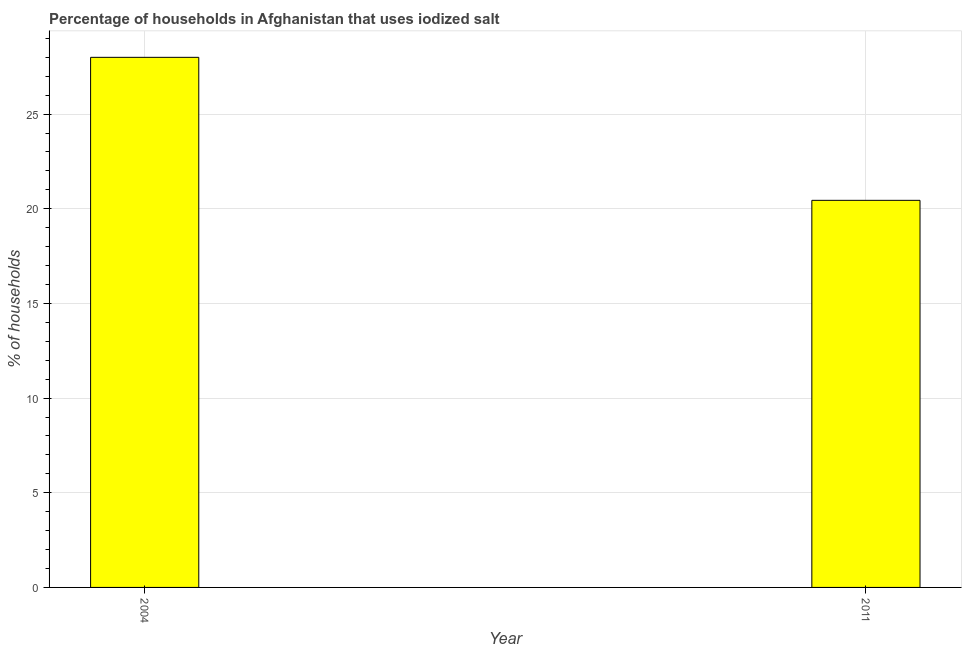Does the graph contain any zero values?
Your response must be concise. No. Does the graph contain grids?
Give a very brief answer. Yes. What is the title of the graph?
Provide a short and direct response. Percentage of households in Afghanistan that uses iodized salt. What is the label or title of the X-axis?
Your answer should be compact. Year. What is the label or title of the Y-axis?
Provide a short and direct response. % of households. Across all years, what is the minimum percentage of households where iodized salt is consumed?
Keep it short and to the point. 20.45. In which year was the percentage of households where iodized salt is consumed maximum?
Offer a very short reply. 2004. In which year was the percentage of households where iodized salt is consumed minimum?
Your answer should be compact. 2011. What is the sum of the percentage of households where iodized salt is consumed?
Your answer should be compact. 48.45. What is the difference between the percentage of households where iodized salt is consumed in 2004 and 2011?
Your answer should be compact. 7.55. What is the average percentage of households where iodized salt is consumed per year?
Your answer should be very brief. 24.22. What is the median percentage of households where iodized salt is consumed?
Your response must be concise. 24.22. In how many years, is the percentage of households where iodized salt is consumed greater than 1 %?
Offer a terse response. 2. What is the ratio of the percentage of households where iodized salt is consumed in 2004 to that in 2011?
Give a very brief answer. 1.37. In how many years, is the percentage of households where iodized salt is consumed greater than the average percentage of households where iodized salt is consumed taken over all years?
Provide a short and direct response. 1. Are all the bars in the graph horizontal?
Your answer should be very brief. No. What is the difference between two consecutive major ticks on the Y-axis?
Your answer should be very brief. 5. What is the % of households in 2011?
Your response must be concise. 20.45. What is the difference between the % of households in 2004 and 2011?
Keep it short and to the point. 7.55. What is the ratio of the % of households in 2004 to that in 2011?
Provide a succinct answer. 1.37. 